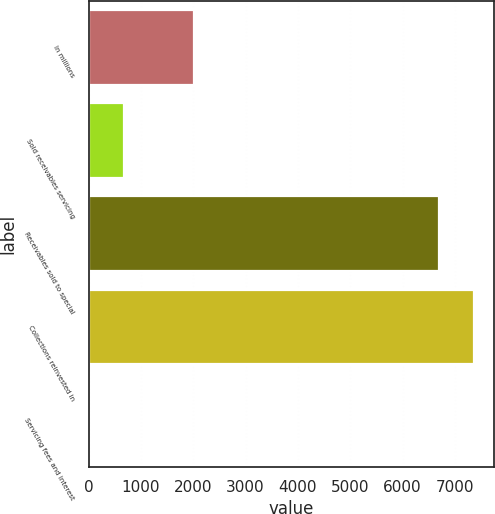Convert chart to OTSL. <chart><loc_0><loc_0><loc_500><loc_500><bar_chart><fcel>In millions<fcel>Sold receivables servicing<fcel>Receivables sold to special<fcel>Collections reinvested in<fcel>Servicing fees and interest<nl><fcel>2008<fcel>681<fcel>6694<fcel>7374<fcel>1<nl></chart> 